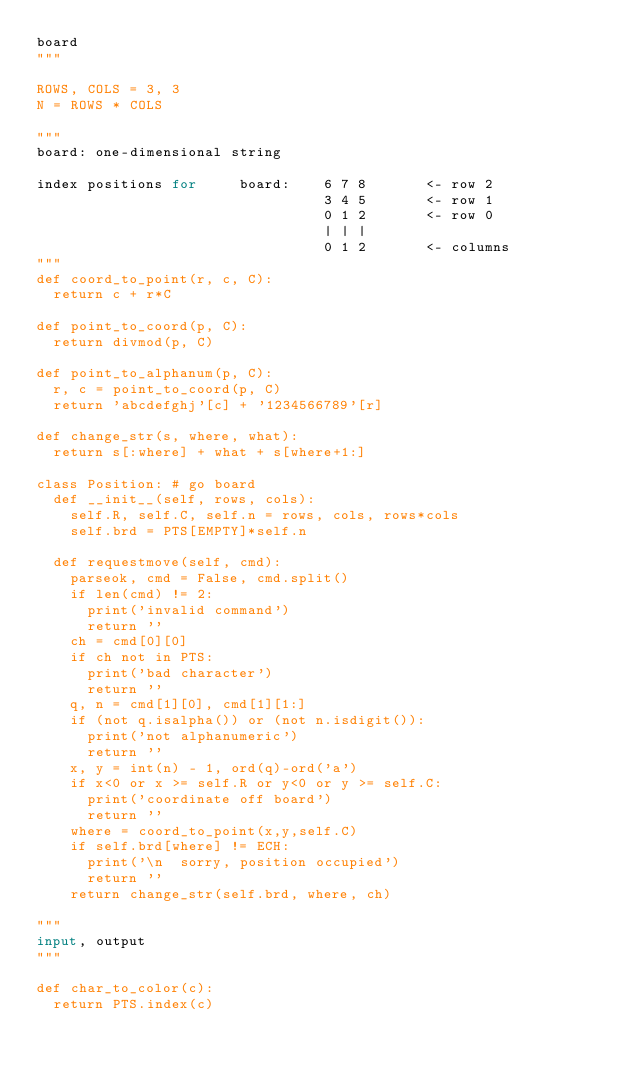<code> <loc_0><loc_0><loc_500><loc_500><_Python_>board
"""

ROWS, COLS = 3, 3
N = ROWS * COLS

"""
board: one-dimensional string

index positions for     board:    6 7 8       <- row 2
                                  3 4 5       <- row 1
                                  0 1 2       <- row 0
                                  | | |
                                  0 1 2       <- columns
"""
def coord_to_point(r, c, C): 
  return c + r*C

def point_to_coord(p, C): 
  return divmod(p, C)

def point_to_alphanum(p, C):
  r, c = point_to_coord(p, C)
  return 'abcdefghj'[c] + '1234566789'[r]

def change_str(s, where, what):
  return s[:where] + what + s[where+1:]

class Position: # go board 
  def __init__(self, rows, cols):
    self.R, self.C, self.n = rows, cols, rows*cols
    self.brd = PTS[EMPTY]*self.n

  def requestmove(self, cmd):
    parseok, cmd = False, cmd.split()
    if len(cmd) != 2:
      print('invalid command')
      return ''
    ch = cmd[0][0]
    if ch not in PTS:
      print('bad character')
      return ''
    q, n = cmd[1][0], cmd[1][1:]
    if (not q.isalpha()) or (not n.isdigit()):
      print('not alphanumeric')
      return ''
    x, y = int(n) - 1, ord(q)-ord('a')
    if x<0 or x >= self.R or y<0 or y >= self.C:
      print('coordinate off board')
      return ''
    where = coord_to_point(x,y,self.C)
    if self.brd[where] != ECH:
      print('\n  sorry, position occupied')
      return ''
    return change_str(self.brd, where, ch)

"""
input, output
"""

def char_to_color(c): 
  return PTS.index(c)
</code> 